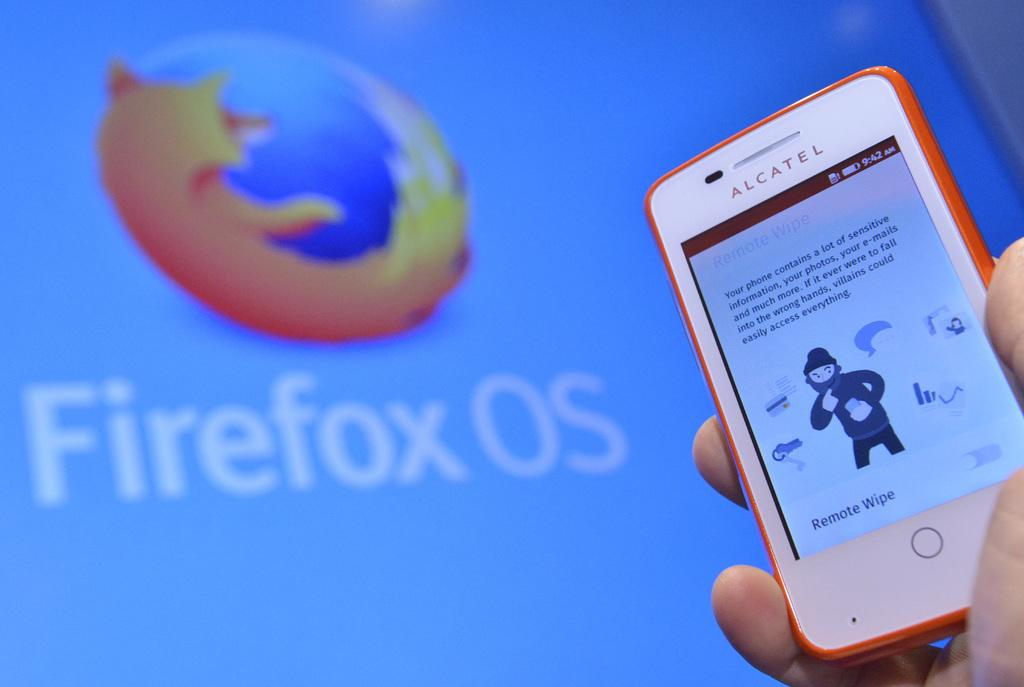<image>
Render a clear and concise summary of the photo. Firefox OS advertisement with the phone in front of it. 